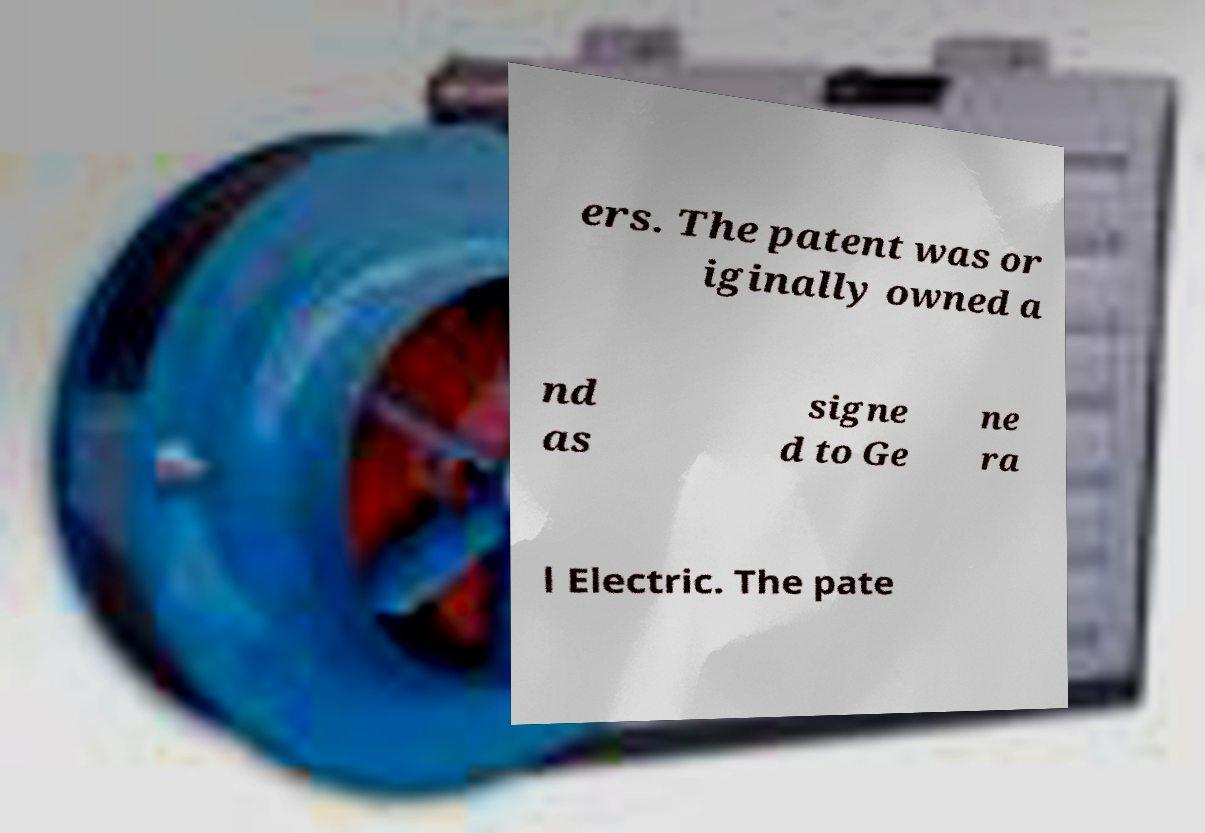There's text embedded in this image that I need extracted. Can you transcribe it verbatim? ers. The patent was or iginally owned a nd as signe d to Ge ne ra l Electric. The pate 